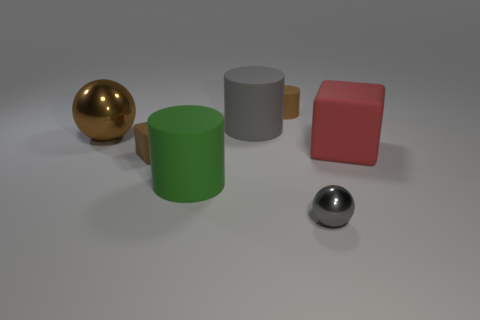Are there any brown rubber things that have the same shape as the big red thing?
Your response must be concise. Yes. Is the color of the matte block that is to the left of the big red thing the same as the tiny cylinder?
Your answer should be very brief. Yes. There is a metal sphere that is in front of the large metallic object; does it have the same size as the brown matte object to the left of the big green object?
Provide a succinct answer. Yes. There is a brown cube that is the same material as the large green cylinder; what is its size?
Offer a terse response. Small. How many big objects are both behind the green rubber object and on the right side of the big brown thing?
Keep it short and to the point. 2. How many objects are small red cylinders or tiny brown matte objects behind the big red cube?
Your answer should be very brief. 1. There is a large metal object that is the same color as the tiny cylinder; what is its shape?
Provide a short and direct response. Sphere. There is a shiny object that is on the right side of the large green thing; what color is it?
Offer a terse response. Gray. What number of objects are either cylinders behind the brown metal thing or large shiny spheres?
Make the answer very short. 3. The matte block that is the same size as the gray cylinder is what color?
Give a very brief answer. Red. 